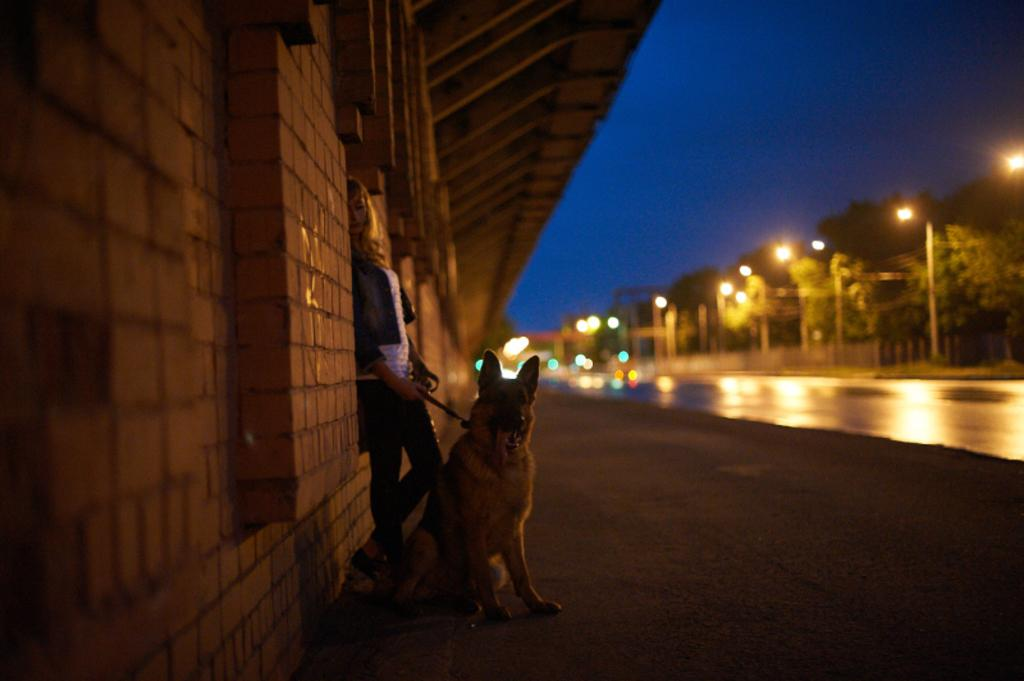Who or what can be seen in the image? There is a person and a dog in the image. What is the person doing with the dog? The person is holding a dog leash. What can be seen in the background of the image? There is a building, light poles, trees, and the sky visible in the background of the image. What type of bells can be heard ringing in the image? There are no bells present in the image, and therefore no sound can be heard. How many birds are perched on the light poles in the image? There are no birds visible in the image, as it only features a person, a dog, a building, light poles, trees, and the sky. 